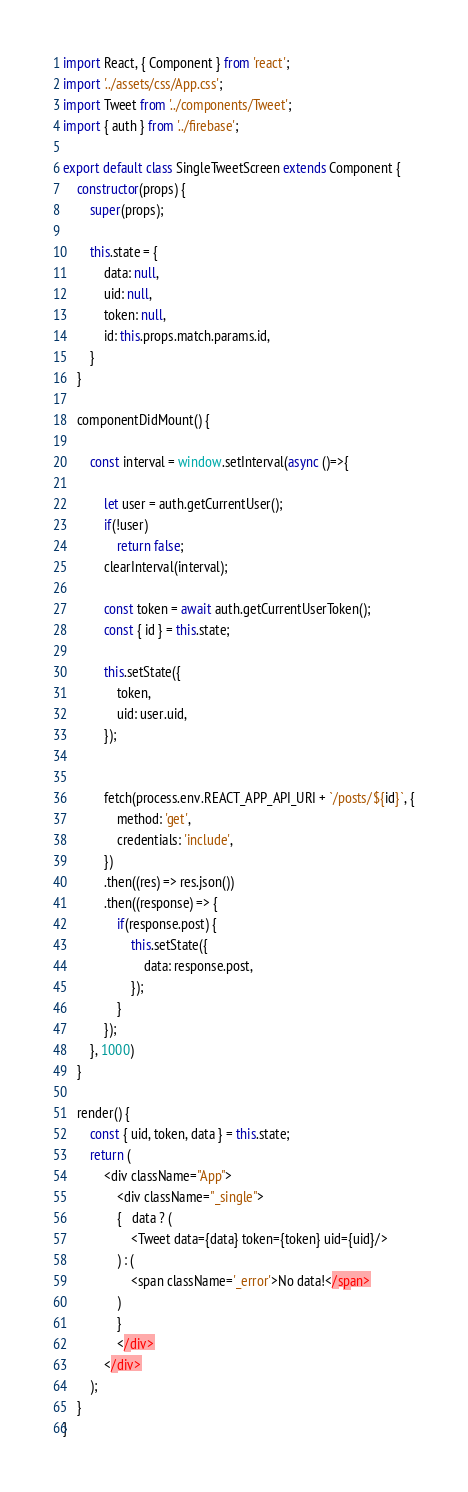<code> <loc_0><loc_0><loc_500><loc_500><_JavaScript_>import React, { Component } from 'react';
import '../assets/css/App.css';
import Tweet from '../components/Tweet';
import { auth } from '../firebase';

export default class SingleTweetScreen extends Component {
    constructor(props) {
        super(props);

        this.state = {
            data: null,
            uid: null,
            token: null,
            id: this.props.match.params.id,
        }
    }

    componentDidMount() {

        const interval = window.setInterval(async ()=>{

            let user = auth.getCurrentUser();
            if(!user)
                return false;
            clearInterval(interval);
            
            const token = await auth.getCurrentUserToken();
            const { id } = this.state;

            this.setState({
                token,
                uid: user.uid,
            });

            
            fetch(process.env.REACT_APP_API_URI + `/posts/${id}`, {
                method: 'get',
                credentials: 'include',
            })
            .then((res) => res.json())
            .then((response) => {
                if(response.post) {
                    this.setState({
                        data: response.post,
                    });
                }
            });
        }, 1000)
    }

    render() {
        const { uid, token, data } = this.state;
        return (
            <div className="App">
                <div className="_single">
                {   data ? (
                    <Tweet data={data} token={token} uid={uid}/>
                ) : (
                    <span className='_error'>No data!</span>
                )
                }
                </div>
            </div>
        );
    }
}</code> 